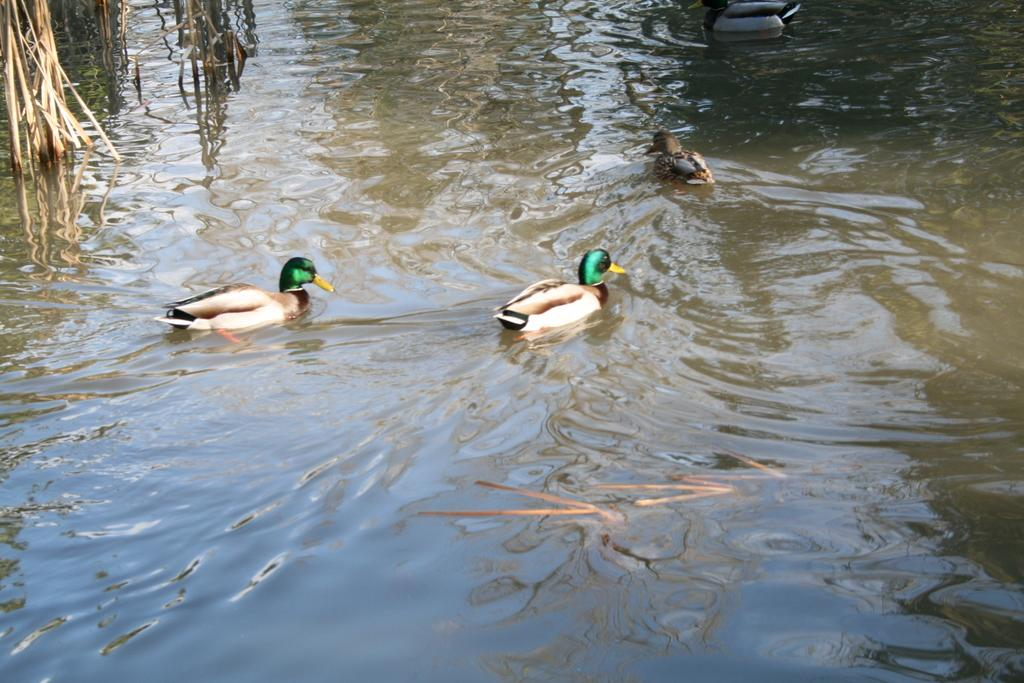What type of animals can be seen in the image? There are ducks in the image. Where are the ducks located? The ducks are in the water. How many boys are controlling the ducks in the image? There are no boys present in the image, and the ducks are not being controlled. 